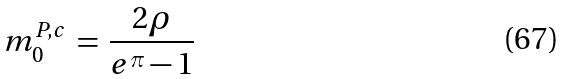Convert formula to latex. <formula><loc_0><loc_0><loc_500><loc_500>m _ { 0 } ^ { P , c } \, = \, \frac { 2 \rho } { e ^ { \pi } - 1 }</formula> 